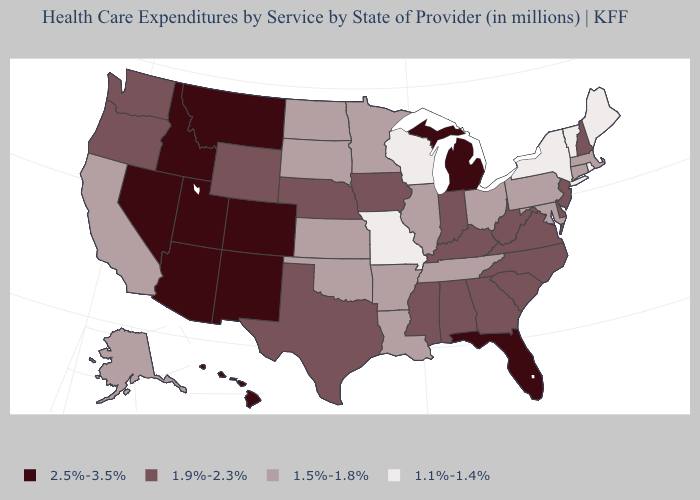Name the states that have a value in the range 1.5%-1.8%?
Concise answer only. Alaska, Arkansas, California, Connecticut, Illinois, Kansas, Louisiana, Maryland, Massachusetts, Minnesota, North Dakota, Ohio, Oklahoma, Pennsylvania, South Dakota, Tennessee. Among the states that border Oregon , does California have the highest value?
Write a very short answer. No. What is the value of West Virginia?
Give a very brief answer. 1.9%-2.3%. Which states have the lowest value in the West?
Be succinct. Alaska, California. Among the states that border Maryland , does Delaware have the highest value?
Be succinct. Yes. What is the lowest value in the USA?
Short answer required. 1.1%-1.4%. Does Virginia have a higher value than Illinois?
Quick response, please. Yes. Does West Virginia have the highest value in the South?
Be succinct. No. Which states have the highest value in the USA?
Quick response, please. Arizona, Colorado, Florida, Hawaii, Idaho, Michigan, Montana, Nevada, New Mexico, Utah. Does Arkansas have a lower value than Connecticut?
Answer briefly. No. Does Michigan have the same value as Maine?
Concise answer only. No. Name the states that have a value in the range 1.1%-1.4%?
Short answer required. Maine, Missouri, New York, Rhode Island, Vermont, Wisconsin. Which states have the lowest value in the Northeast?
Be succinct. Maine, New York, Rhode Island, Vermont. Name the states that have a value in the range 1.1%-1.4%?
Concise answer only. Maine, Missouri, New York, Rhode Island, Vermont, Wisconsin. 